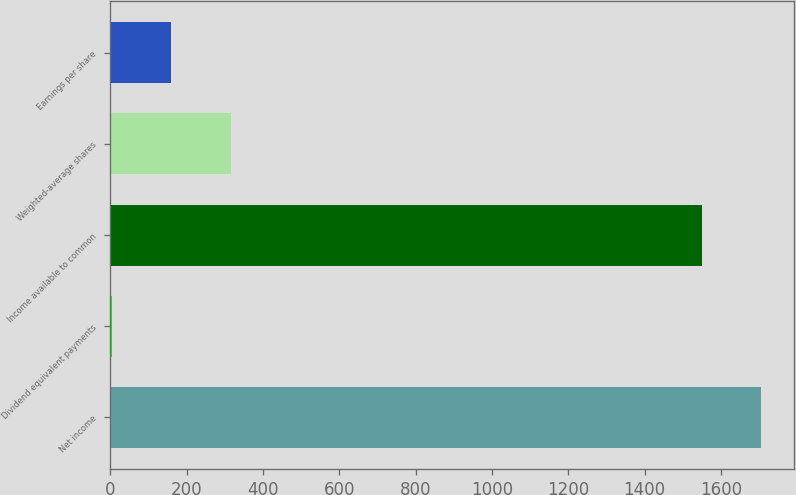Convert chart to OTSL. <chart><loc_0><loc_0><loc_500><loc_500><bar_chart><fcel>Net income<fcel>Dividend equivalent payments<fcel>Income available to common<fcel>Weighted-average shares<fcel>Earnings per share<nl><fcel>1706.1<fcel>5<fcel>1551<fcel>315.2<fcel>160.1<nl></chart> 